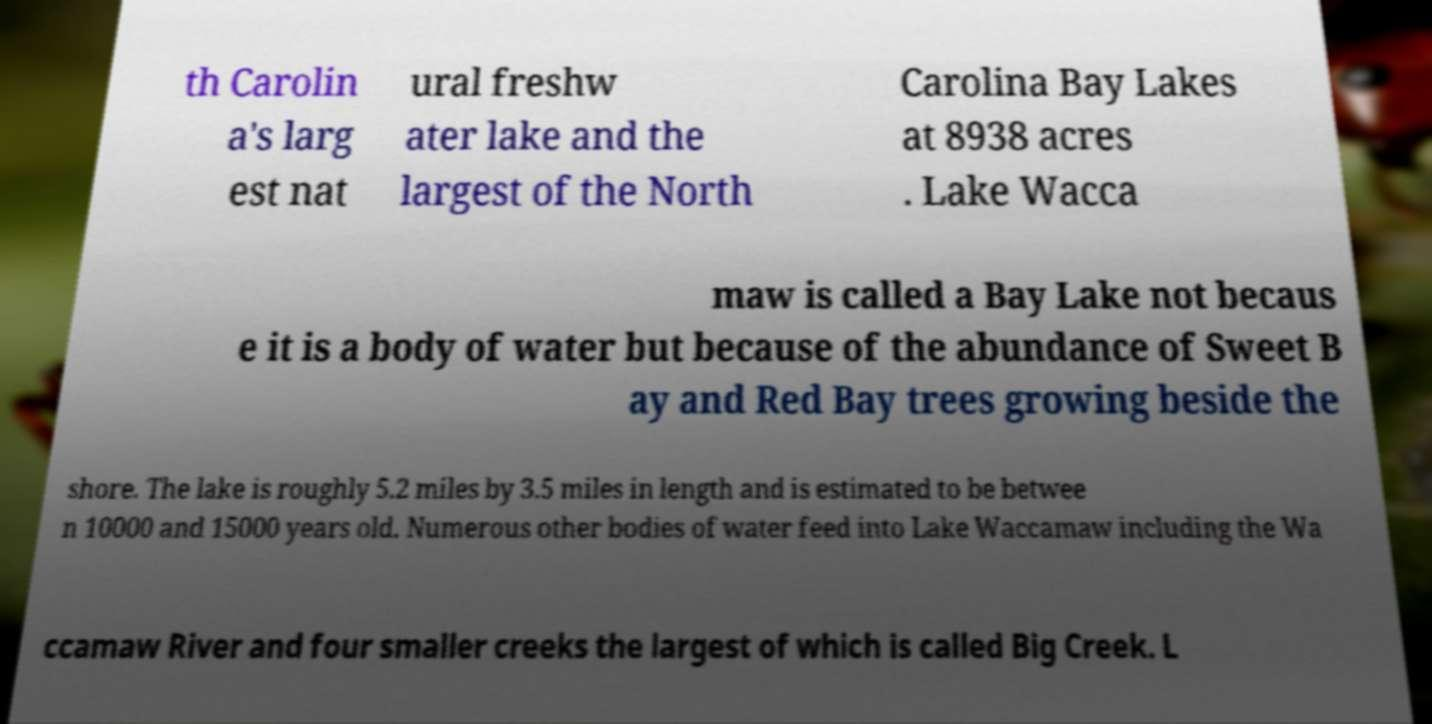Can you read and provide the text displayed in the image?This photo seems to have some interesting text. Can you extract and type it out for me? th Carolin a's larg est nat ural freshw ater lake and the largest of the North Carolina Bay Lakes at 8938 acres . Lake Wacca maw is called a Bay Lake not becaus e it is a body of water but because of the abundance of Sweet B ay and Red Bay trees growing beside the shore. The lake is roughly 5.2 miles by 3.5 miles in length and is estimated to be betwee n 10000 and 15000 years old. Numerous other bodies of water feed into Lake Waccamaw including the Wa ccamaw River and four smaller creeks the largest of which is called Big Creek. L 